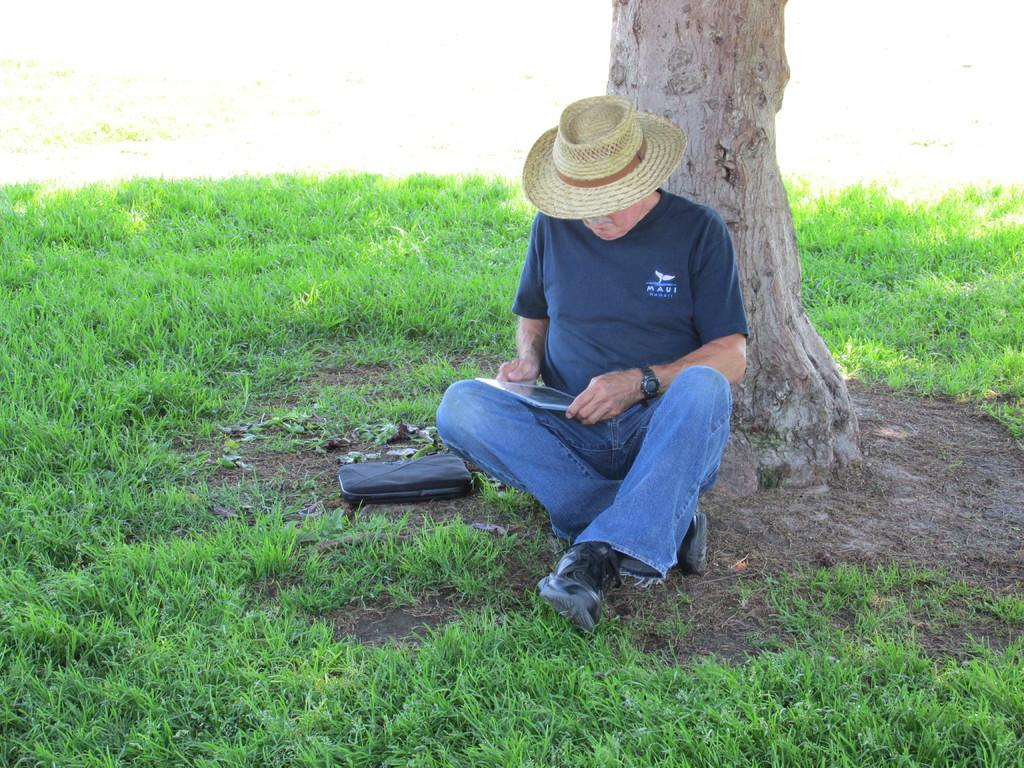What is there is a person in the image, what is he doing? There is a person sitting in the image, and he is holding a tab in his hands. What can be seen in the background of the image? There is a tree in the background of the image. What is the ground covered with at the bottom of the image? The ground is covered with grass at the bottom of the image. How many pies can be seen on the ground in the image? There are no pies present in the image. What type of clover is growing near the tree in the image? There is no clover visible in the image. 